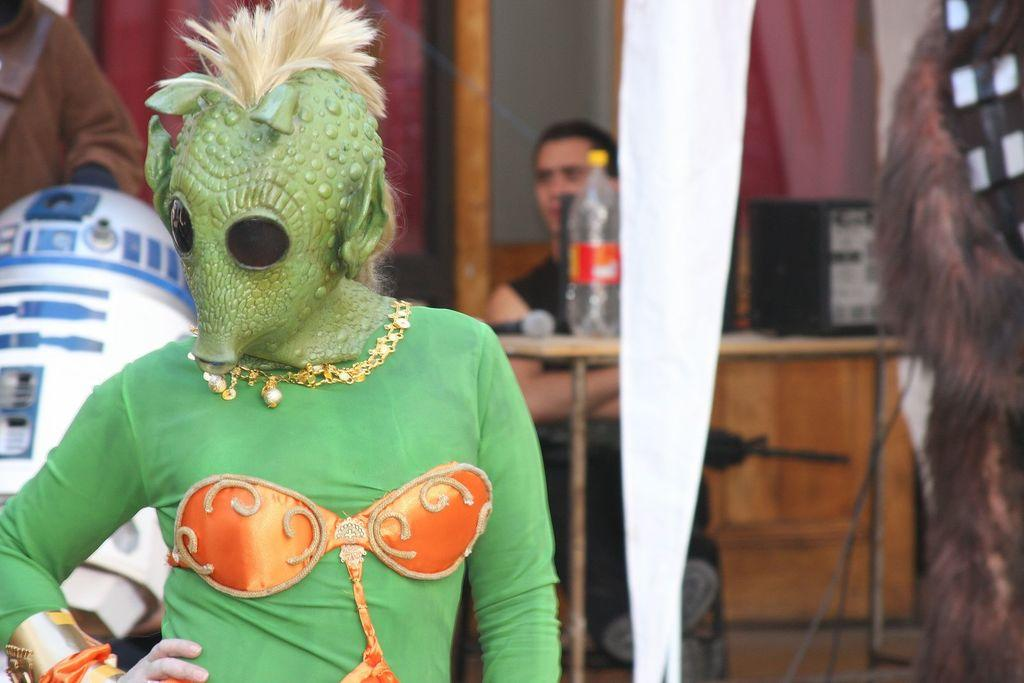What is the person in the image wearing? The person is standing in a green costume in the image. What is the man in the image doing? The man is sitting on a chair in the image. What objects can be seen on the table in the image? A bottle, a microphone (mic), and a black object are visible on the table in the image. What type of amusement can be seen in the image? There is no amusement present in the image; it features a person in a green costume, a man sitting on a chair, and objects on a table. How does the image convey a sense of peace? The image does not convey a sense of peace, as it does not depict any peaceful or calming elements. 